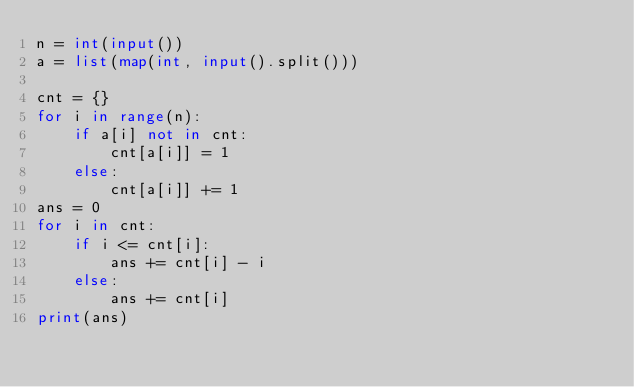<code> <loc_0><loc_0><loc_500><loc_500><_Python_>n = int(input())
a = list(map(int, input().split()))

cnt = {}
for i in range(n):
    if a[i] not in cnt:
        cnt[a[i]] = 1
    else:
        cnt[a[i]] += 1
ans = 0
for i in cnt:
    if i <= cnt[i]:
        ans += cnt[i] - i
    else:
        ans += cnt[i]
print(ans)</code> 